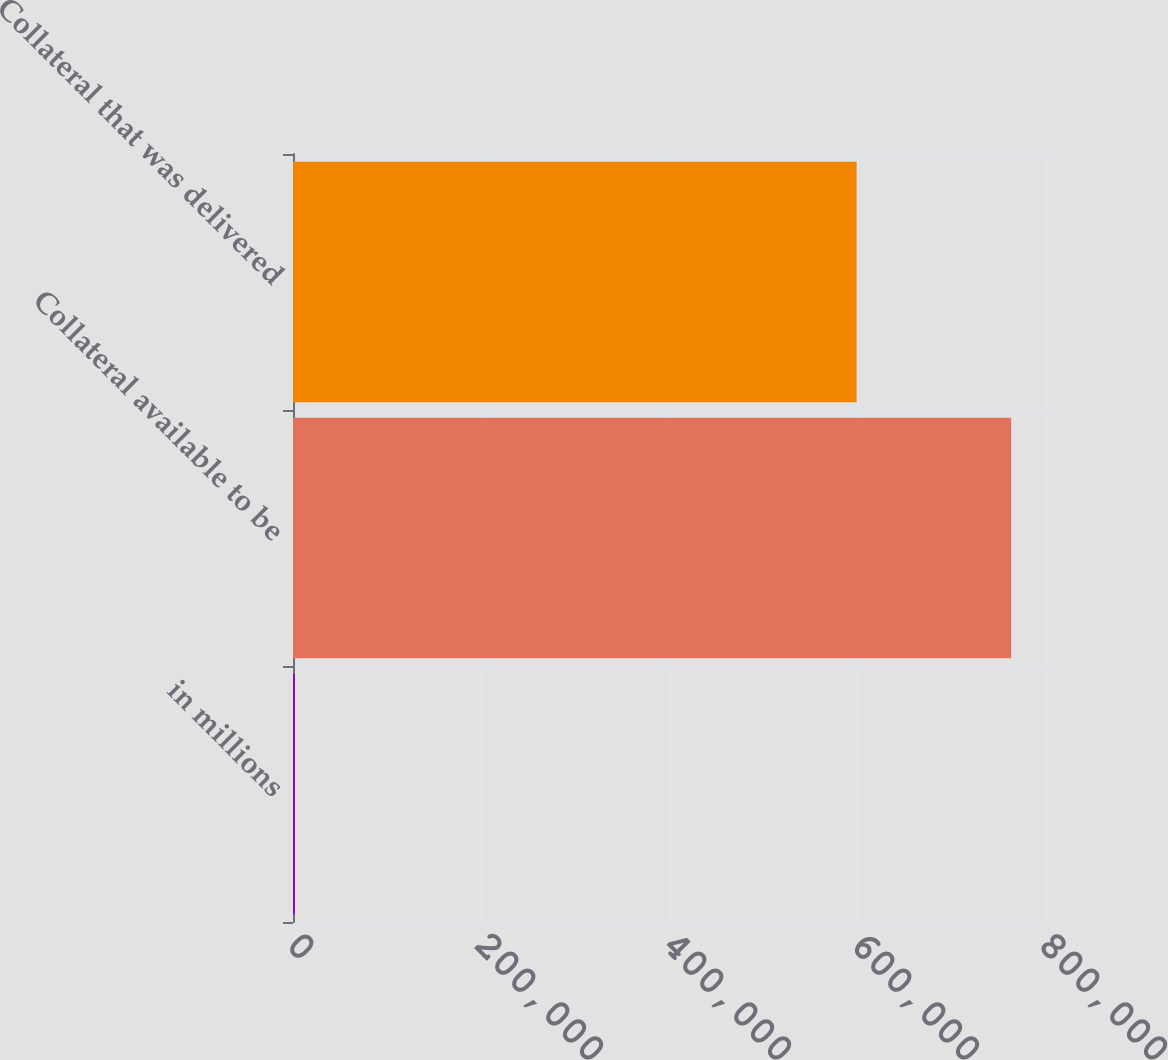<chart> <loc_0><loc_0><loc_500><loc_500><bar_chart><fcel>in millions<fcel>Collateral available to be<fcel>Collateral that was delivered<nl><fcel>2017<fcel>763984<fcel>599565<nl></chart> 